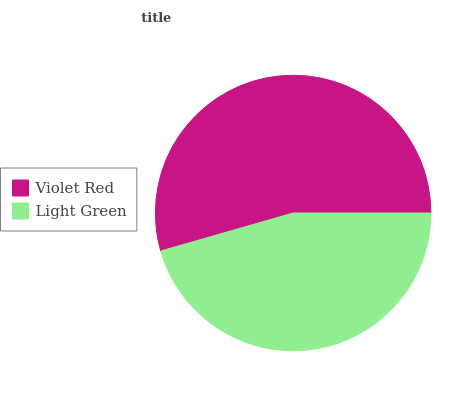Is Light Green the minimum?
Answer yes or no. Yes. Is Violet Red the maximum?
Answer yes or no. Yes. Is Light Green the maximum?
Answer yes or no. No. Is Violet Red greater than Light Green?
Answer yes or no. Yes. Is Light Green less than Violet Red?
Answer yes or no. Yes. Is Light Green greater than Violet Red?
Answer yes or no. No. Is Violet Red less than Light Green?
Answer yes or no. No. Is Violet Red the high median?
Answer yes or no. Yes. Is Light Green the low median?
Answer yes or no. Yes. Is Light Green the high median?
Answer yes or no. No. Is Violet Red the low median?
Answer yes or no. No. 